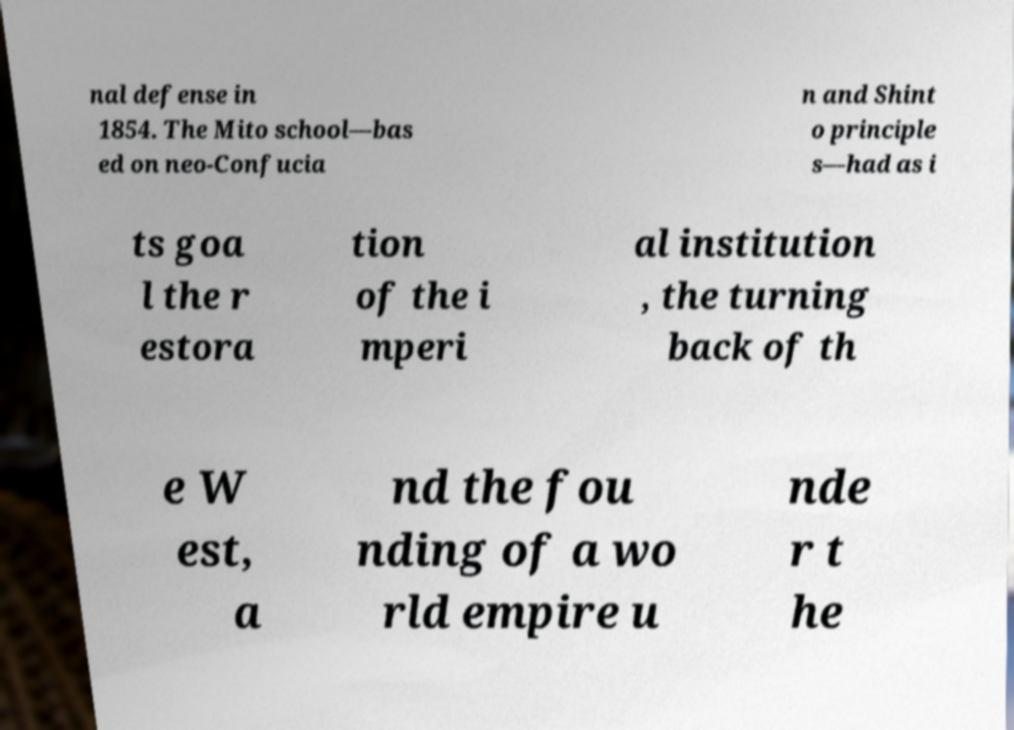Could you extract and type out the text from this image? nal defense in 1854. The Mito school—bas ed on neo-Confucia n and Shint o principle s—had as i ts goa l the r estora tion of the i mperi al institution , the turning back of th e W est, a nd the fou nding of a wo rld empire u nde r t he 